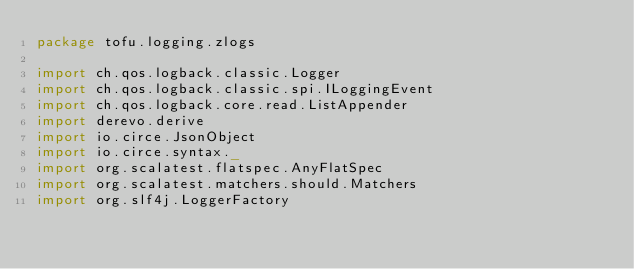<code> <loc_0><loc_0><loc_500><loc_500><_Scala_>package tofu.logging.zlogs

import ch.qos.logback.classic.Logger
import ch.qos.logback.classic.spi.ILoggingEvent
import ch.qos.logback.core.read.ListAppender
import derevo.derive
import io.circe.JsonObject
import io.circe.syntax._
import org.scalatest.flatspec.AnyFlatSpec
import org.scalatest.matchers.should.Matchers
import org.slf4j.LoggerFactory</code> 